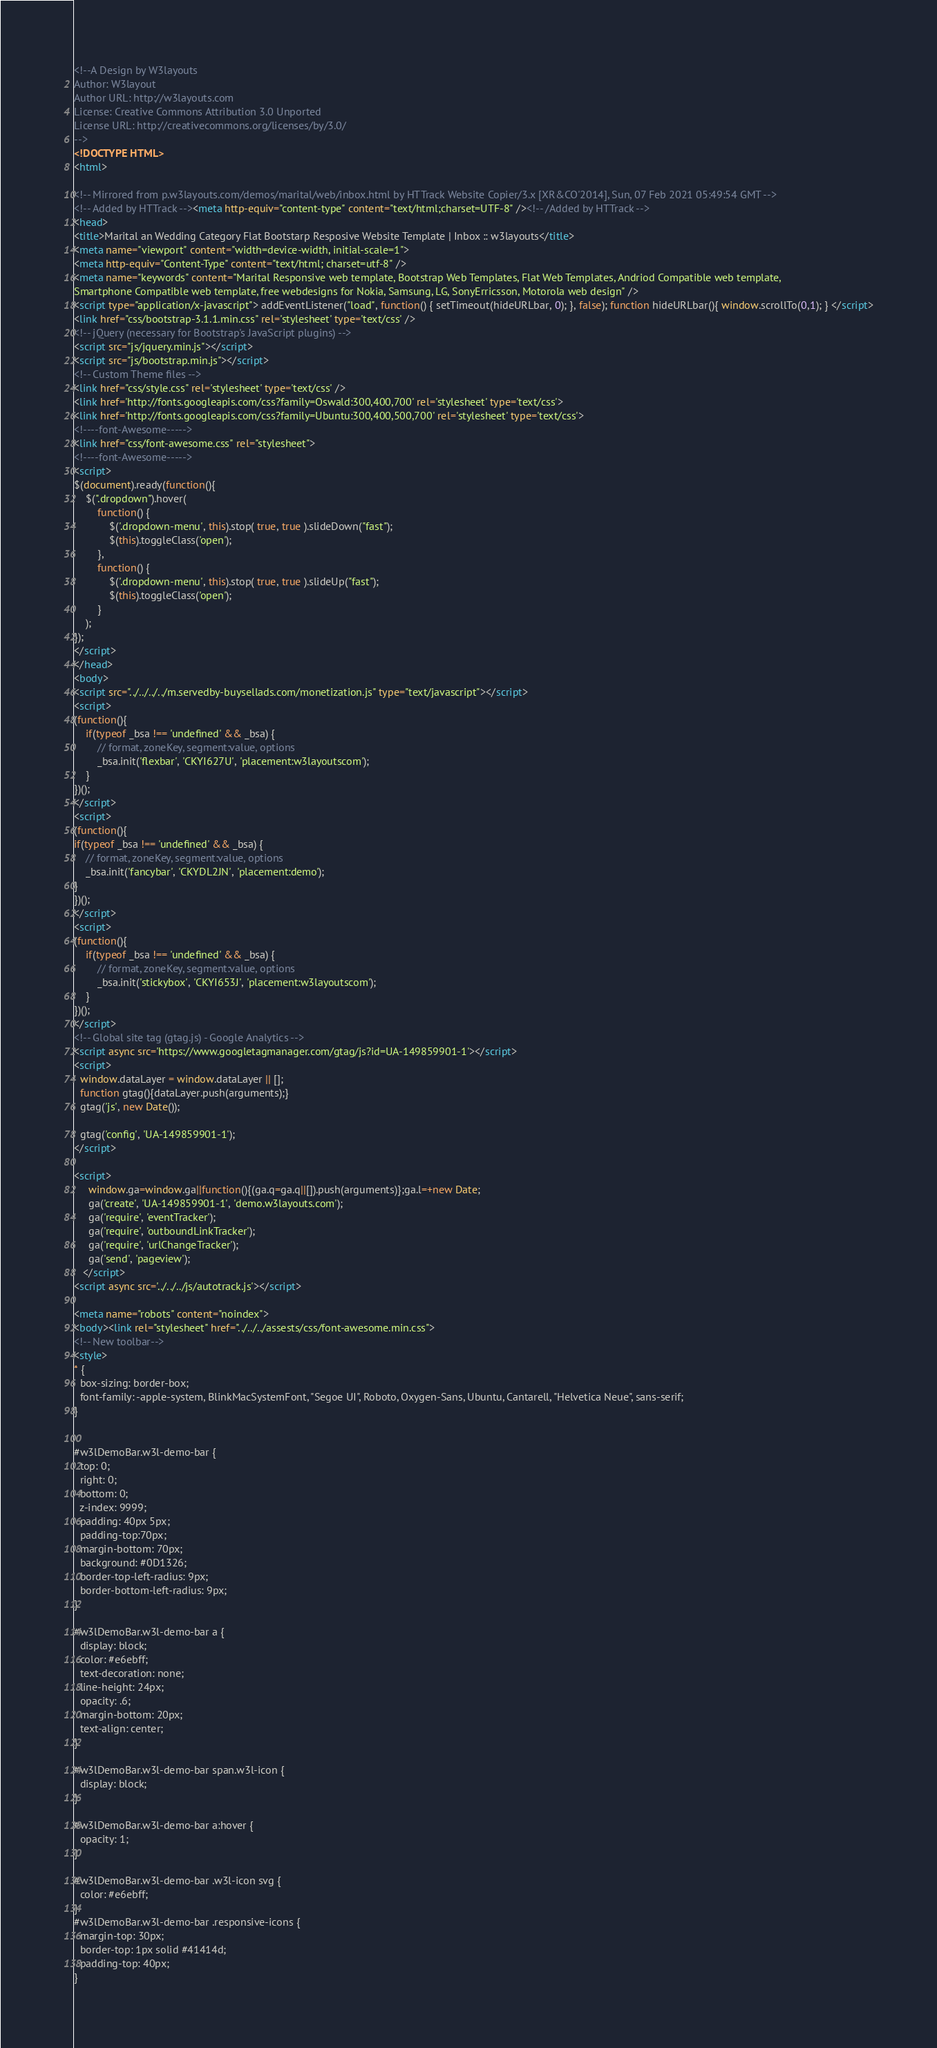<code> <loc_0><loc_0><loc_500><loc_500><_HTML_><!--A Design by W3layouts
Author: W3layout
Author URL: http://w3layouts.com
License: Creative Commons Attribution 3.0 Unported
License URL: http://creativecommons.org/licenses/by/3.0/
-->
<!DOCTYPE HTML>
<html>

<!-- Mirrored from p.w3layouts.com/demos/marital/web/inbox.html by HTTrack Website Copier/3.x [XR&CO'2014], Sun, 07 Feb 2021 05:49:54 GMT -->
<!-- Added by HTTrack --><meta http-equiv="content-type" content="text/html;charset=UTF-8" /><!-- /Added by HTTrack -->
<head>
<title>Marital an Wedding Category Flat Bootstarp Resposive Website Template | Inbox :: w3layouts</title>
<meta name="viewport" content="width=device-width, initial-scale=1">
<meta http-equiv="Content-Type" content="text/html; charset=utf-8" />
<meta name="keywords" content="Marital Responsive web template, Bootstrap Web Templates, Flat Web Templates, Andriod Compatible web template, 
Smartphone Compatible web template, free webdesigns for Nokia, Samsung, LG, SonyErricsson, Motorola web design" />
<script type="application/x-javascript"> addEventListener("load", function() { setTimeout(hideURLbar, 0); }, false); function hideURLbar(){ window.scrollTo(0,1); } </script>
<link href="css/bootstrap-3.1.1.min.css" rel='stylesheet' type='text/css' />
<!-- jQuery (necessary for Bootstrap's JavaScript plugins) -->
<script src="js/jquery.min.js"></script>
<script src="js/bootstrap.min.js"></script>
<!-- Custom Theme files -->
<link href="css/style.css" rel='stylesheet' type='text/css' />
<link href='http://fonts.googleapis.com/css?family=Oswald:300,400,700' rel='stylesheet' type='text/css'>
<link href='http://fonts.googleapis.com/css?family=Ubuntu:300,400,500,700' rel='stylesheet' type='text/css'>
<!----font-Awesome----->
<link href="css/font-awesome.css" rel="stylesheet"> 
<!----font-Awesome----->
<script>
$(document).ready(function(){
    $(".dropdown").hover(            
        function() {
            $('.dropdown-menu', this).stop( true, true ).slideDown("fast");
            $(this).toggleClass('open');        
        },
        function() {
            $('.dropdown-menu', this).stop( true, true ).slideUp("fast");
            $(this).toggleClass('open');       
        }
    );
});
</script>
</head>
<body>
<script src="../../../../m.servedby-buysellads.com/monetization.js" type="text/javascript"></script>
<script>
(function(){
	if(typeof _bsa !== 'undefined' && _bsa) {
  		// format, zoneKey, segment:value, options
  		_bsa.init('flexbar', 'CKYI627U', 'placement:w3layoutscom');
  	}
})();
</script>
<script>
(function(){
if(typeof _bsa !== 'undefined' && _bsa) {
	// format, zoneKey, segment:value, options
	_bsa.init('fancybar', 'CKYDL2JN', 'placement:demo');
}
})();
</script>
<script>
(function(){
	if(typeof _bsa !== 'undefined' && _bsa) {
  		// format, zoneKey, segment:value, options
  		_bsa.init('stickybox', 'CKYI653J', 'placement:w3layoutscom');
  	}
})();
</script>
<!-- Global site tag (gtag.js) - Google Analytics -->
<script async src='https://www.googletagmanager.com/gtag/js?id=UA-149859901-1'></script>
<script>
  window.dataLayer = window.dataLayer || [];
  function gtag(){dataLayer.push(arguments);}
  gtag('js', new Date());

  gtag('config', 'UA-149859901-1');
</script>

<script>
     window.ga=window.ga||function(){(ga.q=ga.q||[]).push(arguments)};ga.l=+new Date;
     ga('create', 'UA-149859901-1', 'demo.w3layouts.com');
     ga('require', 'eventTracker');
     ga('require', 'outboundLinkTracker');
     ga('require', 'urlChangeTracker');
     ga('send', 'pageview');
   </script>
<script async src='../../../js/autotrack.js'></script>

<meta name="robots" content="noindex">
<body><link rel="stylesheet" href="../../../assests/css/font-awesome.min.css">
<!-- New toolbar-->
<style>
* {
  box-sizing: border-box;
  font-family: -apple-system, BlinkMacSystemFont, "Segoe UI", Roboto, Oxygen-Sans, Ubuntu, Cantarell, "Helvetica Neue", sans-serif;
}


#w3lDemoBar.w3l-demo-bar {
  top: 0;
  right: 0;
  bottom: 0;
  z-index: 9999;
  padding: 40px 5px;
  padding-top:70px;
  margin-bottom: 70px;
  background: #0D1326;
  border-top-left-radius: 9px;
  border-bottom-left-radius: 9px;
}

#w3lDemoBar.w3l-demo-bar a {
  display: block;
  color: #e6ebff;
  text-decoration: none;
  line-height: 24px;
  opacity: .6;
  margin-bottom: 20px;
  text-align: center;
}

#w3lDemoBar.w3l-demo-bar span.w3l-icon {
  display: block;
}

#w3lDemoBar.w3l-demo-bar a:hover {
  opacity: 1;
}

#w3lDemoBar.w3l-demo-bar .w3l-icon svg {
  color: #e6ebff;
}
#w3lDemoBar.w3l-demo-bar .responsive-icons {
  margin-top: 30px;
  border-top: 1px solid #41414d;
  padding-top: 40px;
}</code> 